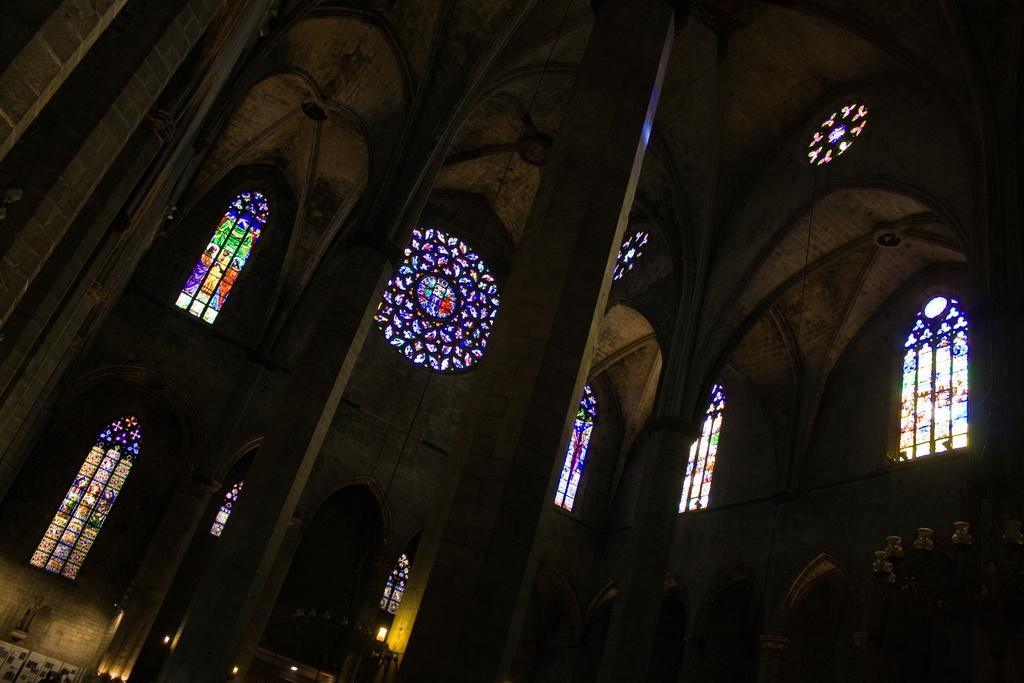Describe this image in one or two sentences. In this image, I can see the inside view of a building with the pillars. I think these are the windows with the glass doors. I can see the glass paintings on the windows. 